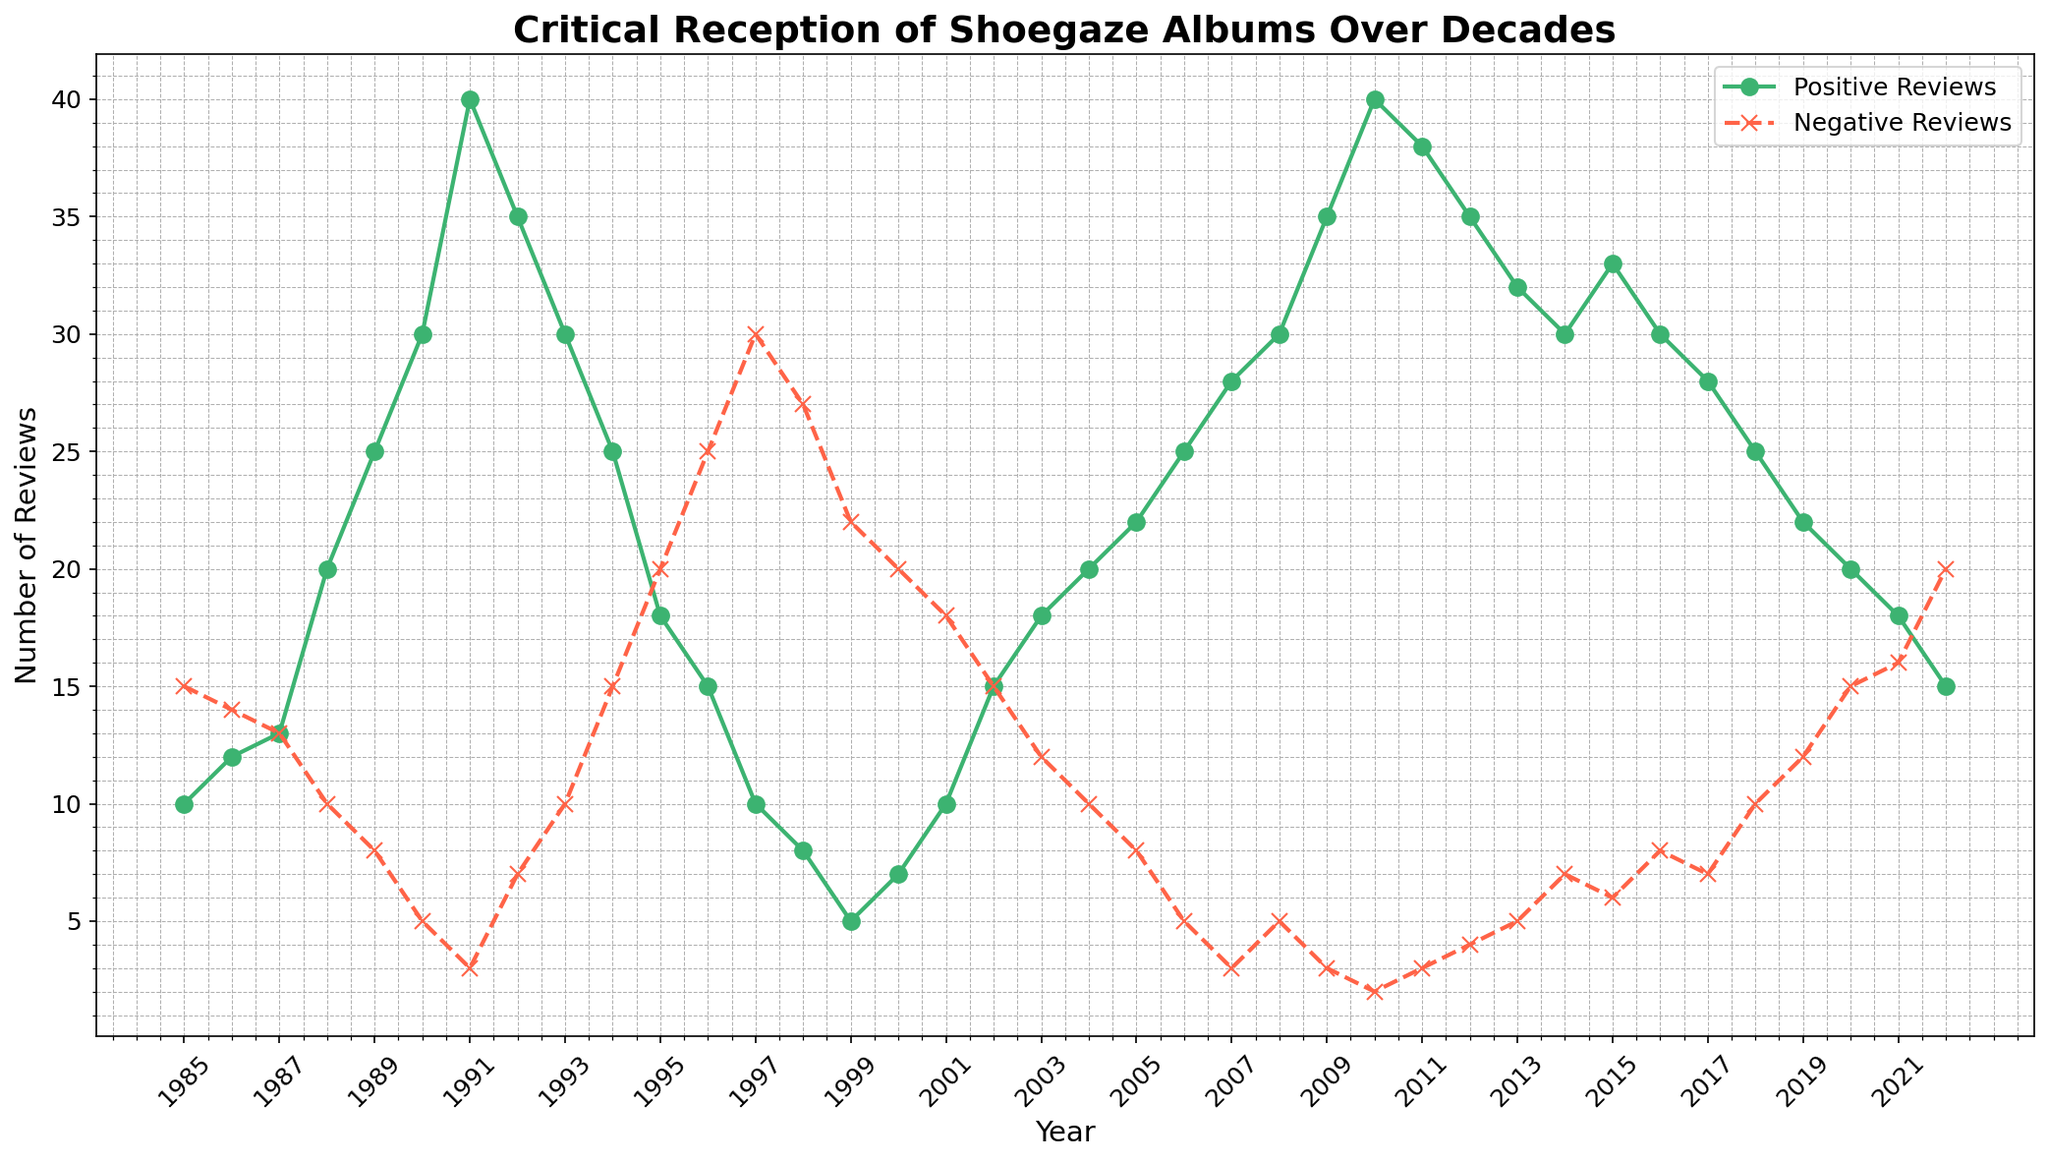What's the highest number of positive reviews, and in which year did it occur? The highest number of positive reviews can be found by looking at the peak of the line for positive reviews. The peak value is 40, which occurs in 1991 and also in 2010.
Answer: 40, 1991 and 2010 Which year had the lowest number of positive reviews and how many were there? Identify the lowest point on the positive reviews line. The lowest visible point has 5 positive reviews in 1999.
Answer: 1999, 5 How do the positive and negative reviews compare in 2007? Find the points for 2007 on both lines. The positive reviews are at 28, and the negative reviews are at 3.
Answer: Positive: 28, Negative: 3 In which year did the number of negative reviews first drop below 10? Track the line representing negative reviews until it first drops below the value of 10. This occurs in 1988 with 10 negative reviews. The next year already drops below 10 in 1989.
Answer: 1989 What’s the difference between positive and negative reviews in 1994? For 1994, note the values for positive and negative reviews and subtract the negative reviews from the positive reviews: (25 - 15) = 10.
Answer: 10 Compare the total number of reviews (positive and negative) in 1995 and 2022: how do they differ? Add positive and negative reviews for each year and compare. In 1995, total reviews are (18 + 20) = 38. In 2022, total reviews are (15 + 20) = 35. The difference is 38 - 35 = 3.
Answer: 3 Which decade (80s, 90s, 00s, or 10s) had the highest average number of positive reviews? Calculate the average number of positive reviews for each decade: 
80s: (10+12+13+20+25)/5 = 16 
90s: (30+40+35+30+25+18+15+10+8+5)/10 = 21.6 
00s: (7+10+15+18+20+22+25+28+30+35)/10 = 21 
10s: (40+38+35+32+30+33+30+28+25+22)/10 = 31.3 
The highest is in the 2010s with 31.3 positive reviews.
Answer: 2010s How many years had more positive reviews than negative reviews? Observe the chart and count the number of years where the positive review line is above the negative review line: 1988 to 2022, excluding 1985 to 1987, 1994 to 1995, 2020 to 2022. Number of counted years is 25.
Answer: 25 Identify a year when both positive and negative reviews were equal, and state the number of reviews. Locate a year where the positive and negative review lines intersect and have the same value. This occurs in 1987 and 2002, and the number of reviews is 13 and 15, respectively.
Answer: 1987, 13 and 2002, 15 